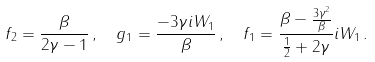Convert formula to latex. <formula><loc_0><loc_0><loc_500><loc_500>& f _ { 2 } = \frac { \beta } { 2 \gamma - 1 } \, , \quad g _ { 1 } = \frac { - 3 \gamma i W _ { 1 } } { \beta } \, , \quad f _ { 1 } = \frac { \beta - \frac { 3 \gamma ^ { 2 } } { \beta } } { \frac { 1 } { 2 } + 2 \gamma } i W _ { 1 } \, .</formula> 